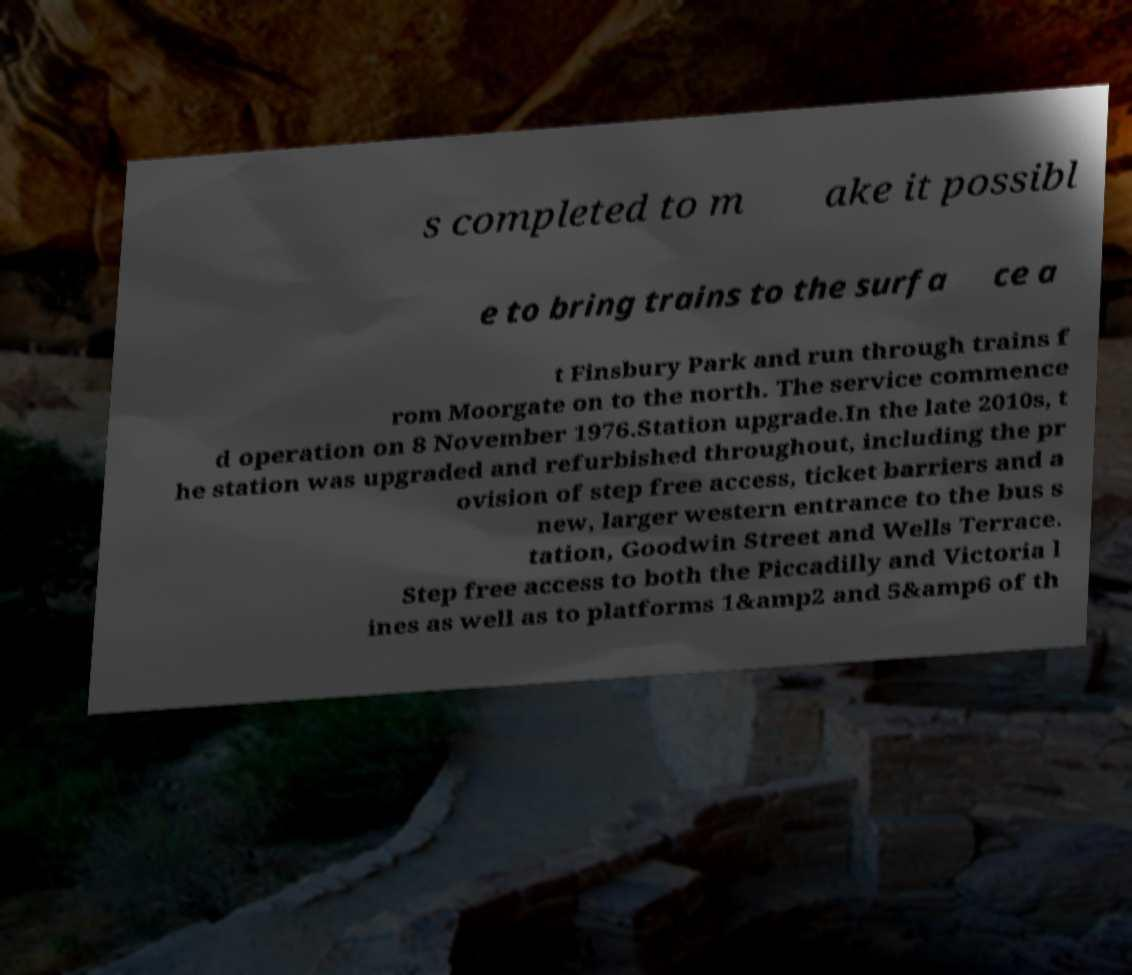Please read and relay the text visible in this image. What does it say? s completed to m ake it possibl e to bring trains to the surfa ce a t Finsbury Park and run through trains f rom Moorgate on to the north. The service commence d operation on 8 November 1976.Station upgrade.In the late 2010s, t he station was upgraded and refurbished throughout, including the pr ovision of step free access, ticket barriers and a new, larger western entrance to the bus s tation, Goodwin Street and Wells Terrace. Step free access to both the Piccadilly and Victoria l ines as well as to platforms 1&amp2 and 5&amp6 of th 